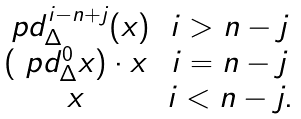Convert formula to latex. <formula><loc_0><loc_0><loc_500><loc_500>\begin{matrix} \ p d ^ { i - n + j } _ { \Delta } ( x ) & i > n - j \\ ( \ p d ^ { 0 } _ { \Delta } x ) \cdot x & i = n - j \\ x & i < n - j . \end{matrix}</formula> 